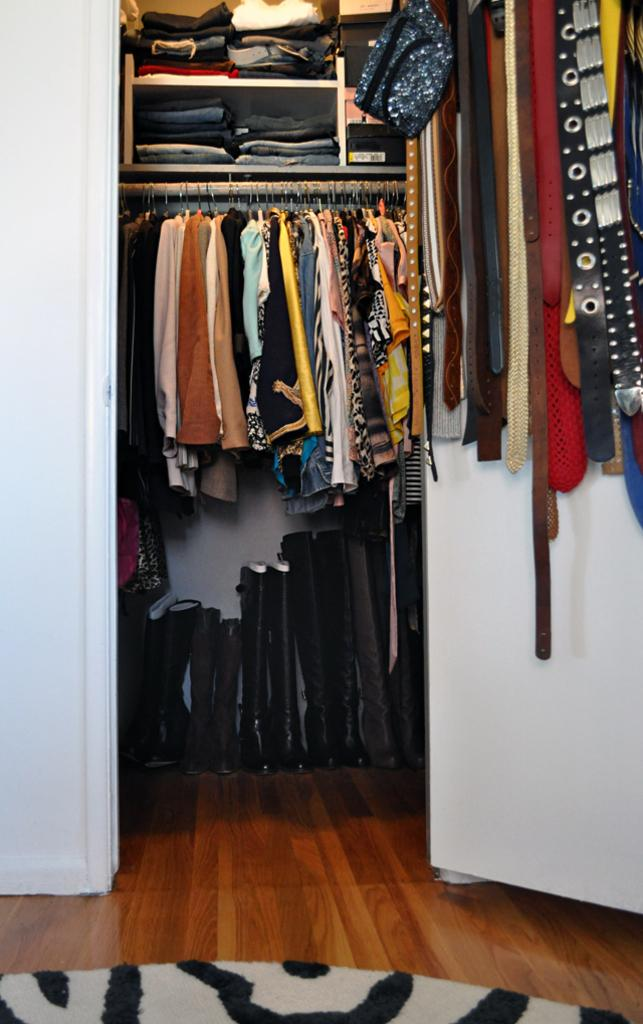What type of furniture is present in the image? There is a wardrobe in the image. What is stored inside the wardrobe? The wardrobe contains clothes. What additional feature does the wardrobe have? The wardrobe includes a shelf unit. What type of accessory can be seen on the right side of the image? There are belts on the right side of the image. What type of flooring is visible in the image? There is a wooden floor visible in the image. What is placed on the wooden floor? There is a floor mat on the wooden floor. What invention is being demonstrated in the image? There is no invention being demonstrated in the image; it features a wardrobe with clothes and accessories. Can you describe the garden visible in the image? There is no garden present in the image; it is focused on the wardrobe and its contents. 